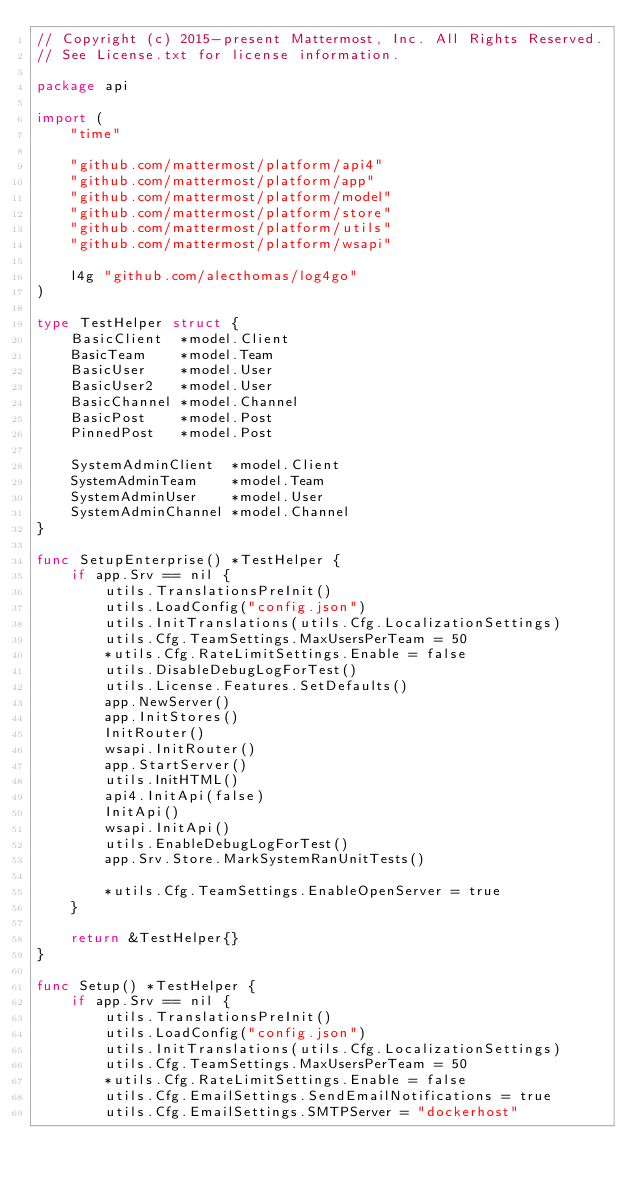Convert code to text. <code><loc_0><loc_0><loc_500><loc_500><_Go_>// Copyright (c) 2015-present Mattermost, Inc. All Rights Reserved.
// See License.txt for license information.

package api

import (
	"time"

	"github.com/mattermost/platform/api4"
	"github.com/mattermost/platform/app"
	"github.com/mattermost/platform/model"
	"github.com/mattermost/platform/store"
	"github.com/mattermost/platform/utils"
	"github.com/mattermost/platform/wsapi"

	l4g "github.com/alecthomas/log4go"
)

type TestHelper struct {
	BasicClient  *model.Client
	BasicTeam    *model.Team
	BasicUser    *model.User
	BasicUser2   *model.User
	BasicChannel *model.Channel
	BasicPost    *model.Post
	PinnedPost   *model.Post

	SystemAdminClient  *model.Client
	SystemAdminTeam    *model.Team
	SystemAdminUser    *model.User
	SystemAdminChannel *model.Channel
}

func SetupEnterprise() *TestHelper {
	if app.Srv == nil {
		utils.TranslationsPreInit()
		utils.LoadConfig("config.json")
		utils.InitTranslations(utils.Cfg.LocalizationSettings)
		utils.Cfg.TeamSettings.MaxUsersPerTeam = 50
		*utils.Cfg.RateLimitSettings.Enable = false
		utils.DisableDebugLogForTest()
		utils.License.Features.SetDefaults()
		app.NewServer()
		app.InitStores()
		InitRouter()
		wsapi.InitRouter()
		app.StartServer()
		utils.InitHTML()
		api4.InitApi(false)
		InitApi()
		wsapi.InitApi()
		utils.EnableDebugLogForTest()
		app.Srv.Store.MarkSystemRanUnitTests()

		*utils.Cfg.TeamSettings.EnableOpenServer = true
	}

	return &TestHelper{}
}

func Setup() *TestHelper {
	if app.Srv == nil {
		utils.TranslationsPreInit()
		utils.LoadConfig("config.json")
		utils.InitTranslations(utils.Cfg.LocalizationSettings)
		utils.Cfg.TeamSettings.MaxUsersPerTeam = 50
		*utils.Cfg.RateLimitSettings.Enable = false
		utils.Cfg.EmailSettings.SendEmailNotifications = true
		utils.Cfg.EmailSettings.SMTPServer = "dockerhost"</code> 